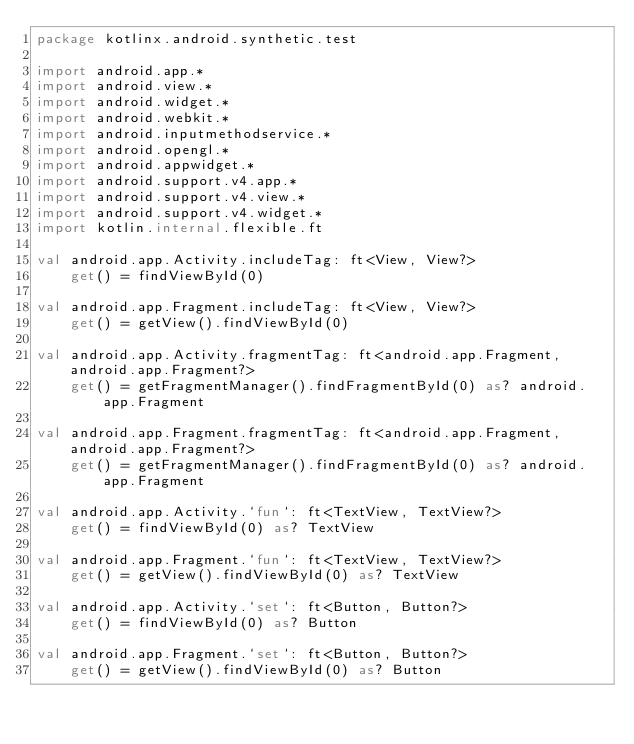<code> <loc_0><loc_0><loc_500><loc_500><_Kotlin_>package kotlinx.android.synthetic.test

import android.app.*
import android.view.*
import android.widget.*
import android.webkit.*
import android.inputmethodservice.*
import android.opengl.*
import android.appwidget.*
import android.support.v4.app.*
import android.support.v4.view.*
import android.support.v4.widget.*
import kotlin.internal.flexible.ft

val android.app.Activity.includeTag: ft<View, View?>
    get() = findViewById(0)

val android.app.Fragment.includeTag: ft<View, View?>
    get() = getView().findViewById(0)

val android.app.Activity.fragmentTag: ft<android.app.Fragment, android.app.Fragment?>
    get() = getFragmentManager().findFragmentById(0) as? android.app.Fragment

val android.app.Fragment.fragmentTag: ft<android.app.Fragment, android.app.Fragment?>
    get() = getFragmentManager().findFragmentById(0) as? android.app.Fragment

val android.app.Activity.`fun`: ft<TextView, TextView?>
    get() = findViewById(0) as? TextView

val android.app.Fragment.`fun`: ft<TextView, TextView?>
    get() = getView().findViewById(0) as? TextView

val android.app.Activity.`set`: ft<Button, Button?>
    get() = findViewById(0) as? Button

val android.app.Fragment.`set`: ft<Button, Button?>
    get() = getView().findViewById(0) as? Button

</code> 